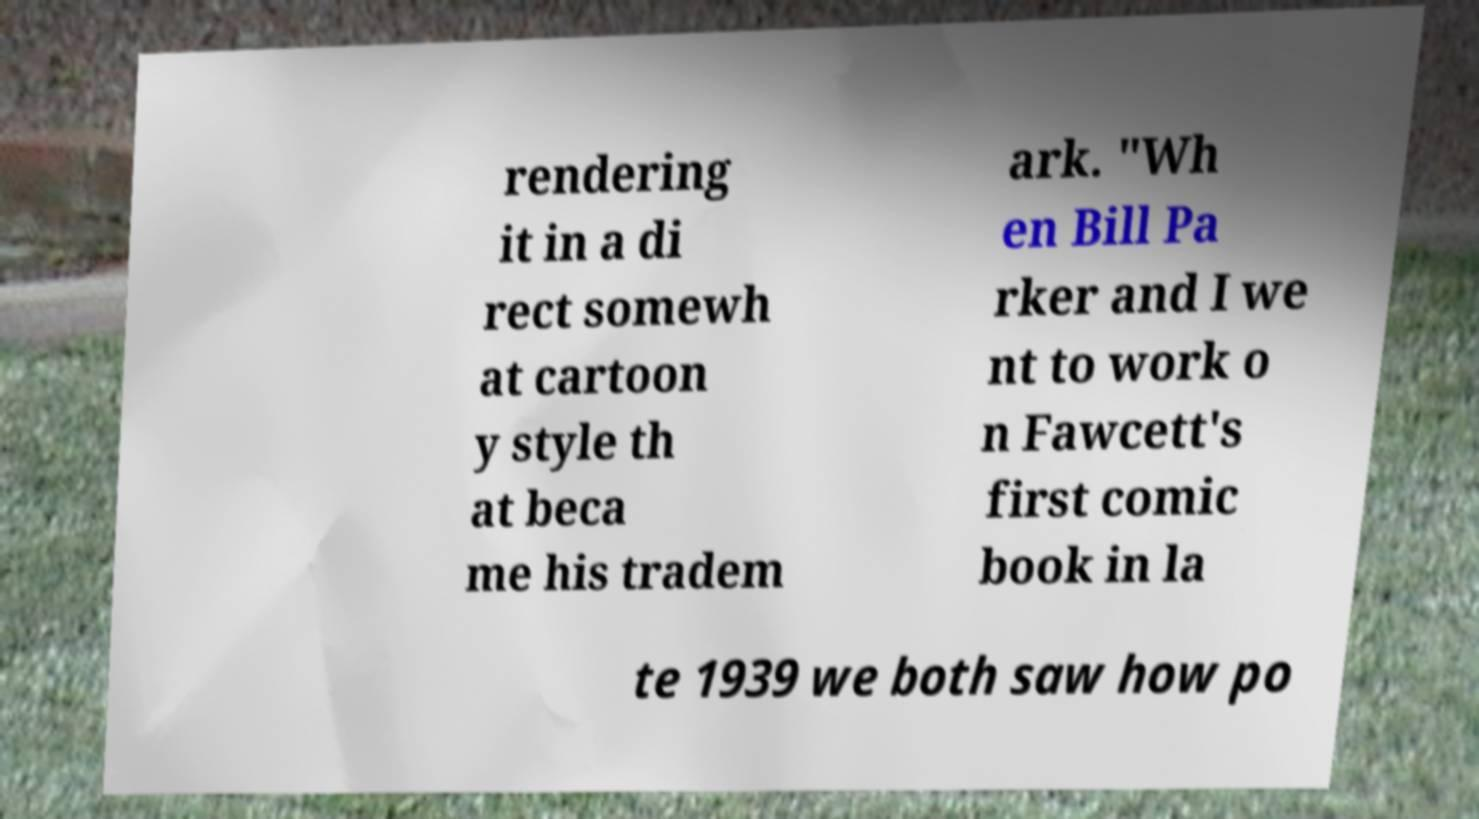Can you read and provide the text displayed in the image?This photo seems to have some interesting text. Can you extract and type it out for me? rendering it in a di rect somewh at cartoon y style th at beca me his tradem ark. "Wh en Bill Pa rker and I we nt to work o n Fawcett's first comic book in la te 1939 we both saw how po 